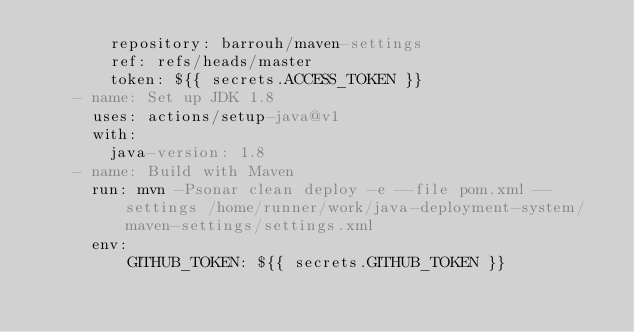Convert code to text. <code><loc_0><loc_0><loc_500><loc_500><_YAML_>        repository: barrouh/maven-settings
        ref: refs/heads/master
        token: ${{ secrets.ACCESS_TOKEN }}
    - name: Set up JDK 1.8
      uses: actions/setup-java@v1
      with:
        java-version: 1.8
    - name: Build with Maven
      run: mvn -Psonar clean deploy -e --file pom.xml --settings /home/runner/work/java-deployment-system/maven-settings/settings.xml
      env:
          GITHUB_TOKEN: ${{ secrets.GITHUB_TOKEN }}
</code> 